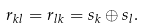<formula> <loc_0><loc_0><loc_500><loc_500>r _ { k l } = r _ { l k } = s _ { k } \oplus s _ { l } .</formula> 